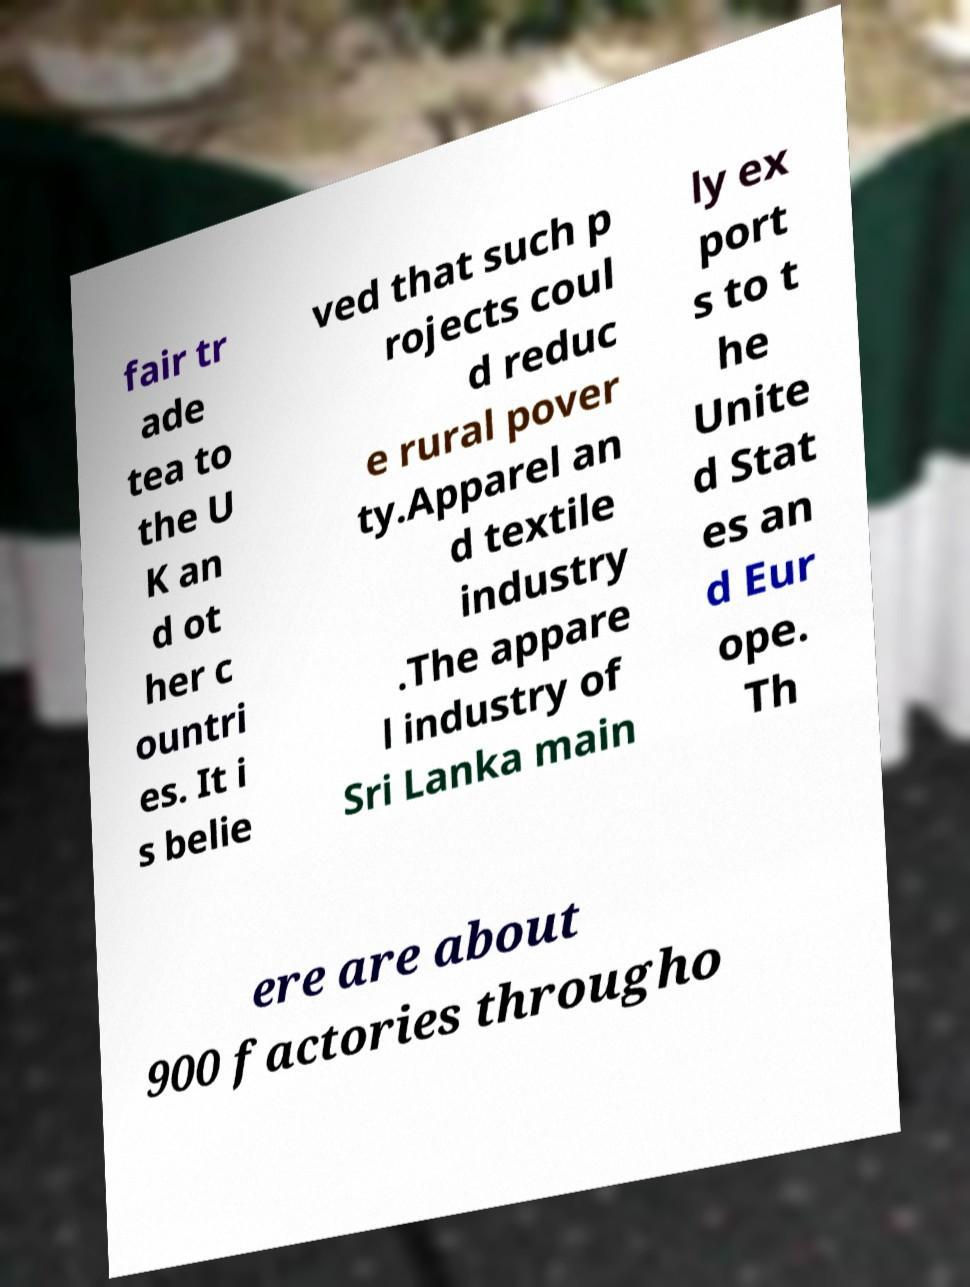For documentation purposes, I need the text within this image transcribed. Could you provide that? fair tr ade tea to the U K an d ot her c ountri es. It i s belie ved that such p rojects coul d reduc e rural pover ty.Apparel an d textile industry .The appare l industry of Sri Lanka main ly ex port s to t he Unite d Stat es an d Eur ope. Th ere are about 900 factories througho 